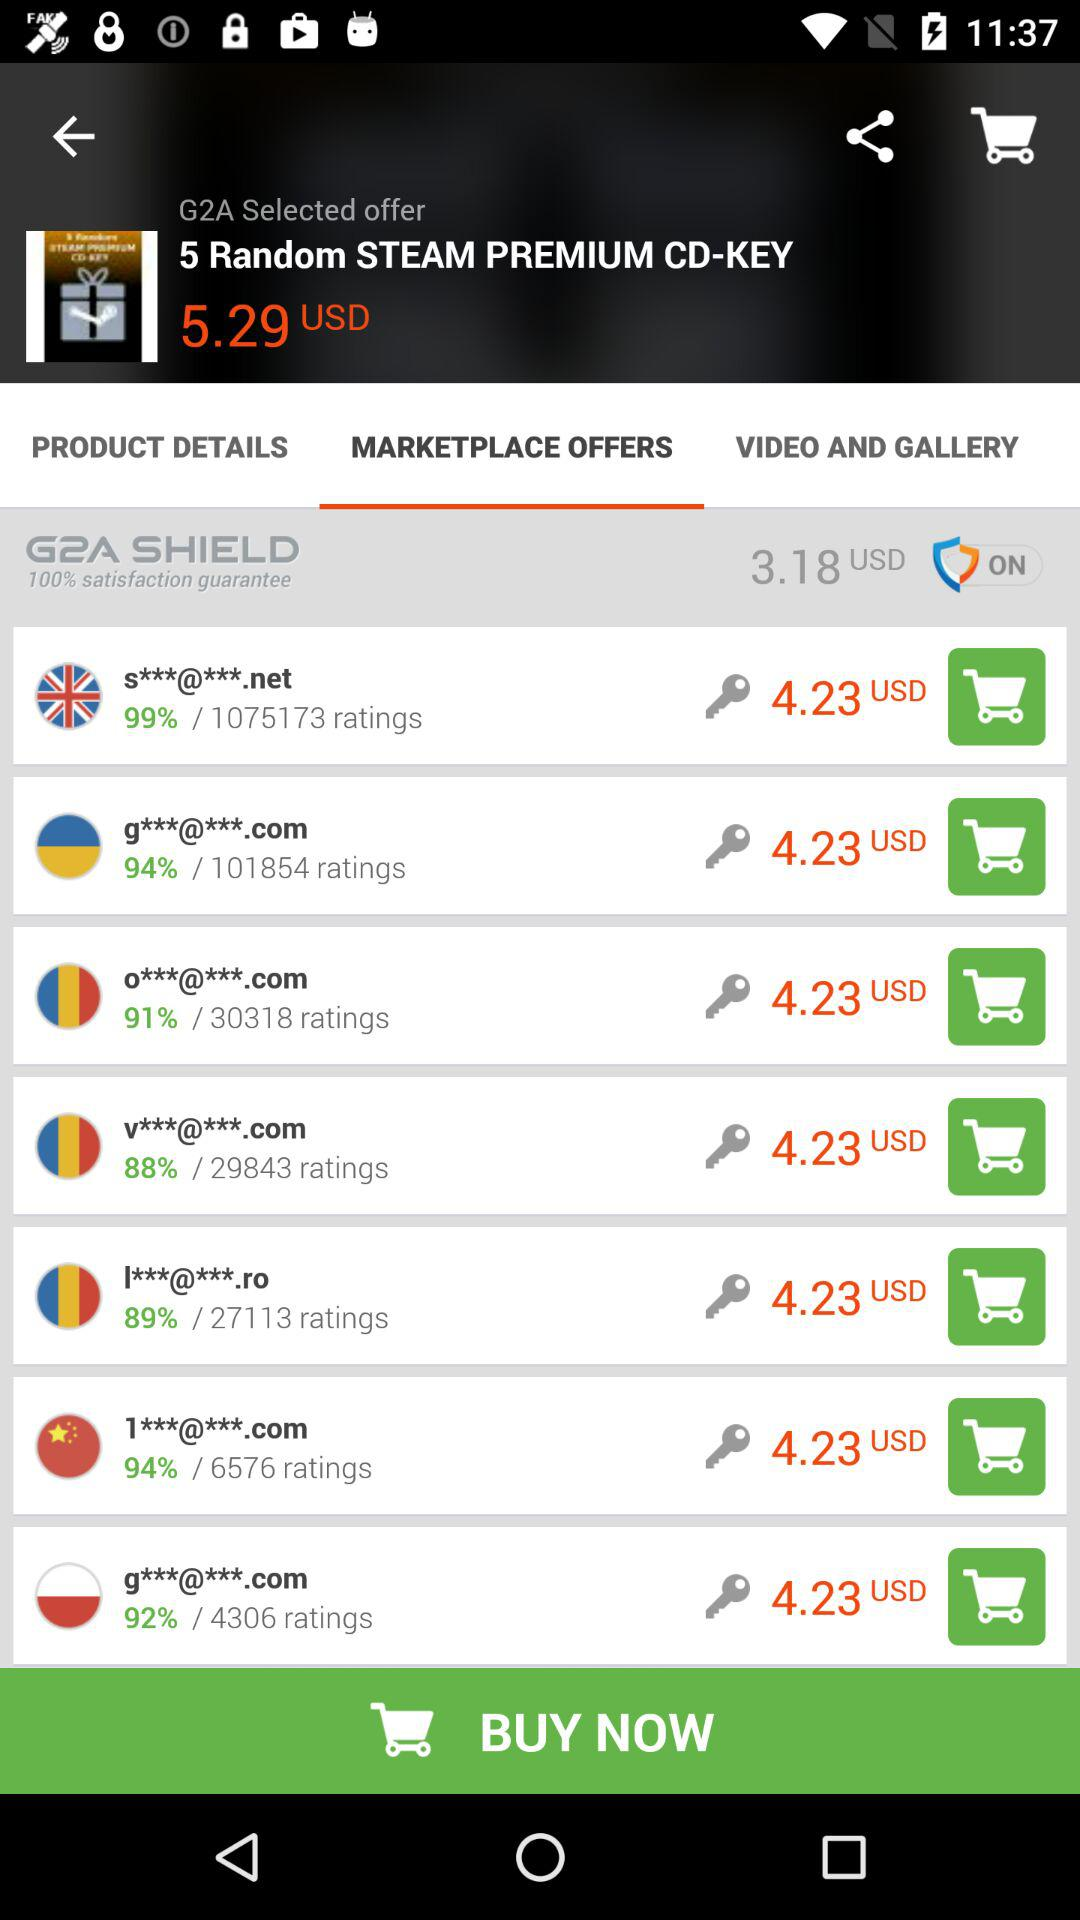Which option is selected? The selected option is "MARKETPLACE OFFERS". 